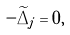<formula> <loc_0><loc_0><loc_500><loc_500>- \widetilde { \Delta } _ { j } = 0 ,</formula> 